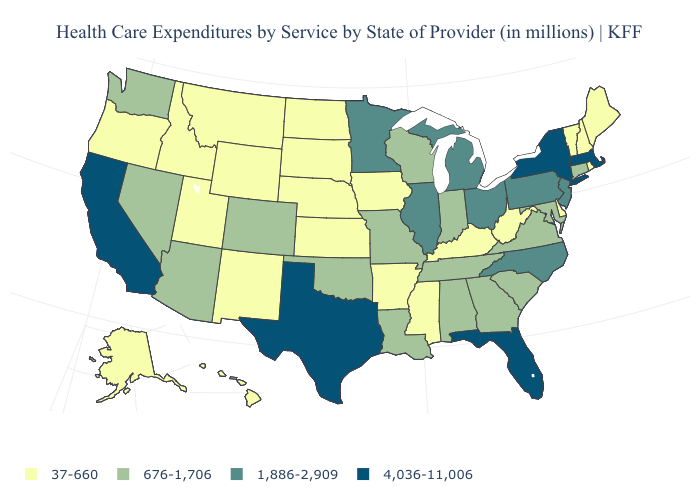Name the states that have a value in the range 37-660?
Concise answer only. Alaska, Arkansas, Delaware, Hawaii, Idaho, Iowa, Kansas, Kentucky, Maine, Mississippi, Montana, Nebraska, New Hampshire, New Mexico, North Dakota, Oregon, Rhode Island, South Dakota, Utah, Vermont, West Virginia, Wyoming. Does the map have missing data?
Concise answer only. No. Does Idaho have the lowest value in the West?
Short answer required. Yes. Which states have the lowest value in the USA?
Keep it brief. Alaska, Arkansas, Delaware, Hawaii, Idaho, Iowa, Kansas, Kentucky, Maine, Mississippi, Montana, Nebraska, New Hampshire, New Mexico, North Dakota, Oregon, Rhode Island, South Dakota, Utah, Vermont, West Virginia, Wyoming. What is the lowest value in states that border Missouri?
Keep it brief. 37-660. Name the states that have a value in the range 4,036-11,006?
Quick response, please. California, Florida, Massachusetts, New York, Texas. What is the lowest value in the USA?
Quick response, please. 37-660. What is the value of Iowa?
Quick response, please. 37-660. Does Oklahoma have the highest value in the USA?
Concise answer only. No. Does Vermont have the same value as Montana?
Give a very brief answer. Yes. Name the states that have a value in the range 676-1,706?
Answer briefly. Alabama, Arizona, Colorado, Connecticut, Georgia, Indiana, Louisiana, Maryland, Missouri, Nevada, Oklahoma, South Carolina, Tennessee, Virginia, Washington, Wisconsin. Does the map have missing data?
Write a very short answer. No. Is the legend a continuous bar?
Keep it brief. No. Is the legend a continuous bar?
Give a very brief answer. No. Among the states that border Connecticut , which have the highest value?
Give a very brief answer. Massachusetts, New York. 